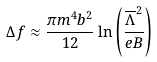<formula> <loc_0><loc_0><loc_500><loc_500>\Delta f \approx \frac { \pi m ^ { 4 } b ^ { 2 } } { 1 2 } \ln \left ( \frac { \overline { \Lambda } ^ { 2 } } { e B } \right )</formula> 